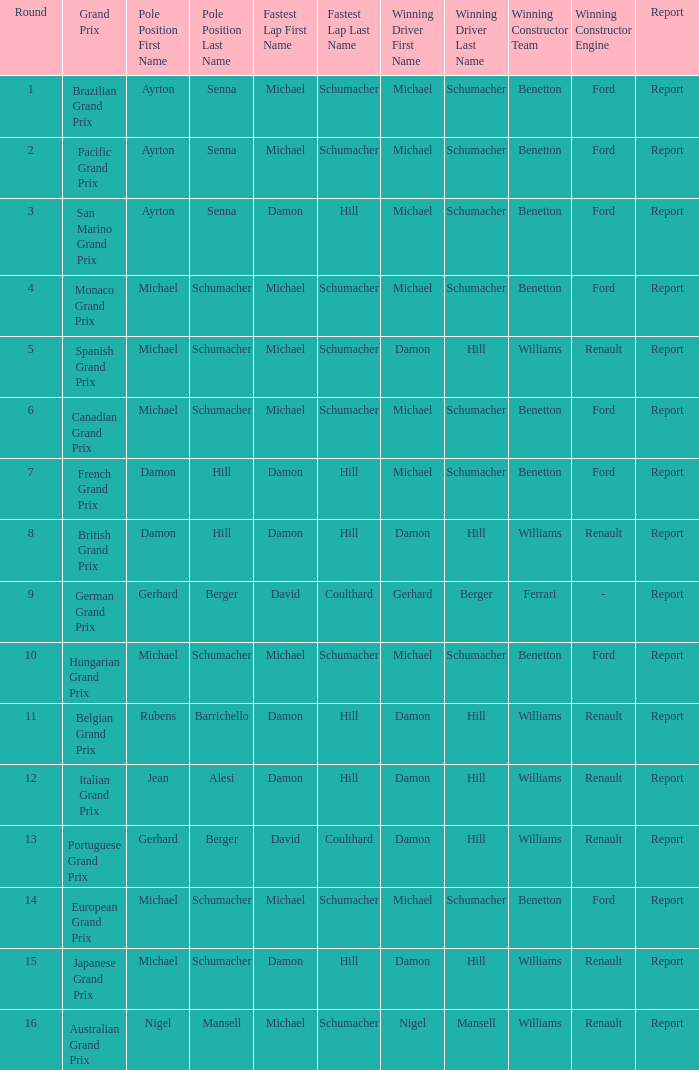Could you parse the entire table as a dict? {'header': ['Round', 'Grand Prix', 'Pole Position First Name', 'Pole Position Last Name', 'Fastest Lap First Name', 'Fastest Lap Last Name', 'Winning Driver First Name', 'Winning Driver Last Name', 'Winning Constructor Team', 'Winning Constructor Engine', 'Report'], 'rows': [['1', 'Brazilian Grand Prix', 'Ayrton', 'Senna', 'Michael', 'Schumacher', 'Michael', 'Schumacher', 'Benetton', 'Ford', 'Report'], ['2', 'Pacific Grand Prix', 'Ayrton', 'Senna', 'Michael', 'Schumacher', 'Michael', 'Schumacher', 'Benetton', 'Ford', 'Report'], ['3', 'San Marino Grand Prix', 'Ayrton', 'Senna', 'Damon', 'Hill', 'Michael', 'Schumacher', 'Benetton', 'Ford', 'Report'], ['4', 'Monaco Grand Prix', 'Michael', 'Schumacher', 'Michael', 'Schumacher', 'Michael', 'Schumacher', 'Benetton', 'Ford', 'Report'], ['5', 'Spanish Grand Prix', 'Michael', 'Schumacher', 'Michael', 'Schumacher', 'Damon', 'Hill', 'Williams', 'Renault', 'Report'], ['6', 'Canadian Grand Prix', 'Michael', 'Schumacher', 'Michael', 'Schumacher', 'Michael', 'Schumacher', 'Benetton', 'Ford', 'Report'], ['7', 'French Grand Prix', 'Damon', 'Hill', 'Damon', 'Hill', 'Michael', 'Schumacher', 'Benetton', 'Ford', 'Report'], ['8', 'British Grand Prix', 'Damon', 'Hill', 'Damon', 'Hill', 'Damon', 'Hill', 'Williams', 'Renault', 'Report'], ['9', 'German Grand Prix', 'Gerhard', 'Berger', 'David', 'Coulthard', 'Gerhard', 'Berger', 'Ferrari', '-', 'Report'], ['10', 'Hungarian Grand Prix', 'Michael', 'Schumacher', 'Michael', 'Schumacher', 'Michael', 'Schumacher', 'Benetton', 'Ford', 'Report'], ['11', 'Belgian Grand Prix', 'Rubens', 'Barrichello', 'Damon', 'Hill', 'Damon', 'Hill', 'Williams', 'Renault', 'Report'], ['12', 'Italian Grand Prix', 'Jean', 'Alesi', 'Damon', 'Hill', 'Damon', 'Hill', 'Williams', 'Renault', 'Report'], ['13', 'Portuguese Grand Prix', 'Gerhard', 'Berger', 'David', 'Coulthard', 'Damon', 'Hill', 'Williams', 'Renault', 'Report'], ['14', 'European Grand Prix', 'Michael', 'Schumacher', 'Michael', 'Schumacher', 'Michael', 'Schumacher', 'Benetton', 'Ford', 'Report'], ['15', 'Japanese Grand Prix', 'Michael', 'Schumacher', 'Damon', 'Hill', 'Damon', 'Hill', 'Williams', 'Renault', 'Report'], ['16', 'Australian Grand Prix', 'Nigel', 'Mansell', 'Michael', 'Schumacher', 'Nigel', 'Mansell', 'Williams', 'Renault', 'Report']]} Name the lowest round for when pole position and winning driver is michael schumacher 4.0. 